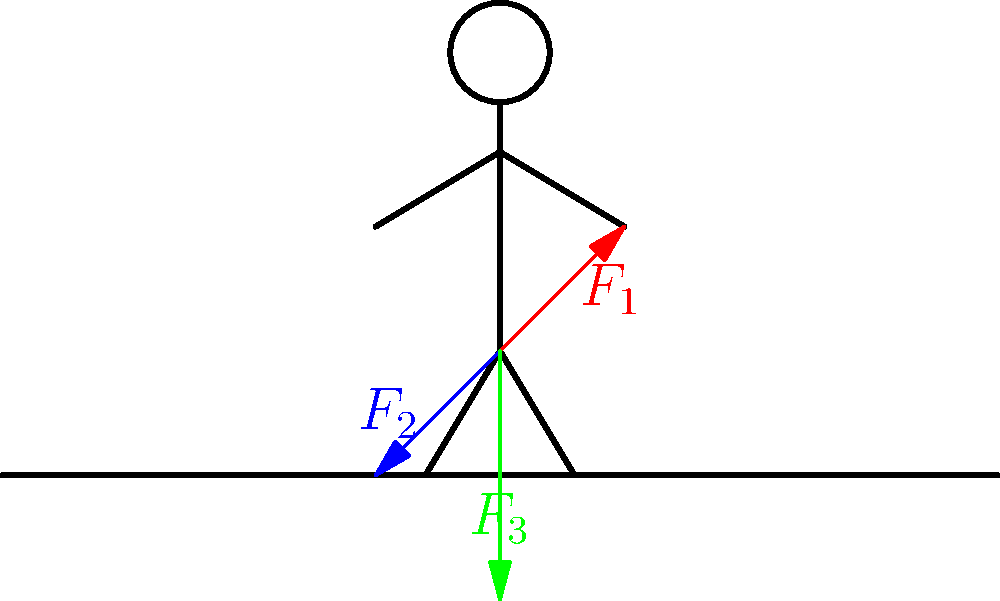As a software engineer preparing for a conference on AI in sports, you come across a biomechanics problem. Consider a sprinter at the starting block, as shown in the diagram. Three force vectors ($F_1$, $F_2$, and $F_3$) are acting on the sprinter. If $F_1 = 200\text{ N}$, $F_2 = 150\text{ N}$, and $F_3 = 250\text{ N}$, what is the magnitude of the resultant force vector acting on the sprinter? To solve this problem, we'll follow these steps:

1) First, we need to understand that the resultant force is the vector sum of all forces acting on the sprinter.

2) We're given three force vectors: $F_1$, $F_2$, and $F_3$. We need to add these vectors.

3) To add vectors, we typically use the component method. We'll need to break each vector into its x and y components.

4) From the diagram:
   - $F_1$ is at approximately 45° to the horizontal
   - $F_2$ is at approximately -45° to the horizontal
   - $F_3$ is straight down (270° or -90°)

5) Let's calculate the components:
   $F_{1x} = 200 \cos 45° = 200 \cdot \frac{\sqrt{2}}{2} \approx 141.4\text{ N}$
   $F_{1y} = 200 \sin 45° = 200 \cdot \frac{\sqrt{2}}{2} \approx 141.4\text{ N}$
   
   $F_{2x} = -150 \cos 45° = -150 \cdot \frac{\sqrt{2}}{2} \approx -106.1\text{ N}$
   $F_{2y} = -150 \sin 45° = -150 \cdot \frac{\sqrt{2}}{2} \approx -106.1\text{ N}$
   
   $F_{3x} = 0\text{ N}$
   $F_{3y} = -250\text{ N}$

6) Now, sum the x and y components:
   $F_x = F_{1x} + F_{2x} + F_{3x} = 141.4 - 106.1 + 0 = 35.3\text{ N}$
   $F_y = F_{1y} + F_{2y} + F_{3y} = 141.4 - 106.1 - 250 = -214.7\text{ N}$

7) The resultant force vector is $(35.3, -214.7)$

8) To find the magnitude of this vector, we use the Pythagorean theorem:
   $|F| = \sqrt{F_x^2 + F_y^2} = \sqrt{35.3^2 + (-214.7)^2} \approx 217.5\text{ N}$

Therefore, the magnitude of the resultant force vector is approximately 217.5 N.
Answer: 217.5 N 